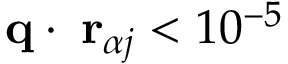Convert formula to latex. <formula><loc_0><loc_0><loc_500><loc_500>{ q } \cdot { \delta r } _ { \alpha j } < 1 0 ^ { - 5 }</formula> 